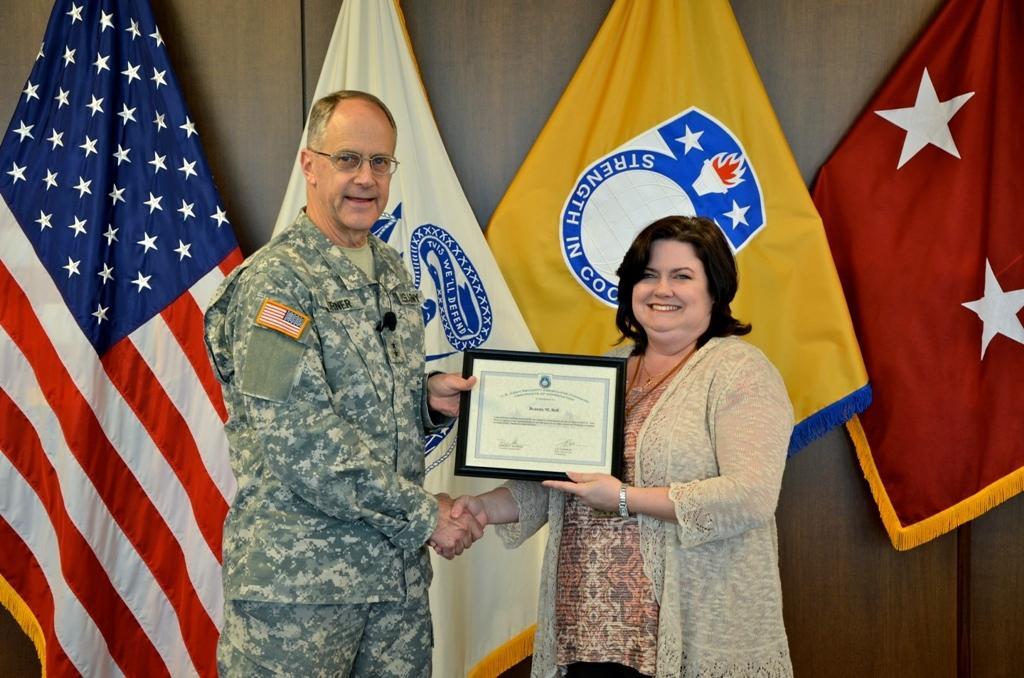Please provide a concise description of this image. In this picture we can see there are two persons standing and holding a certificate. Behind the people, there are flags and a wooden wall. 